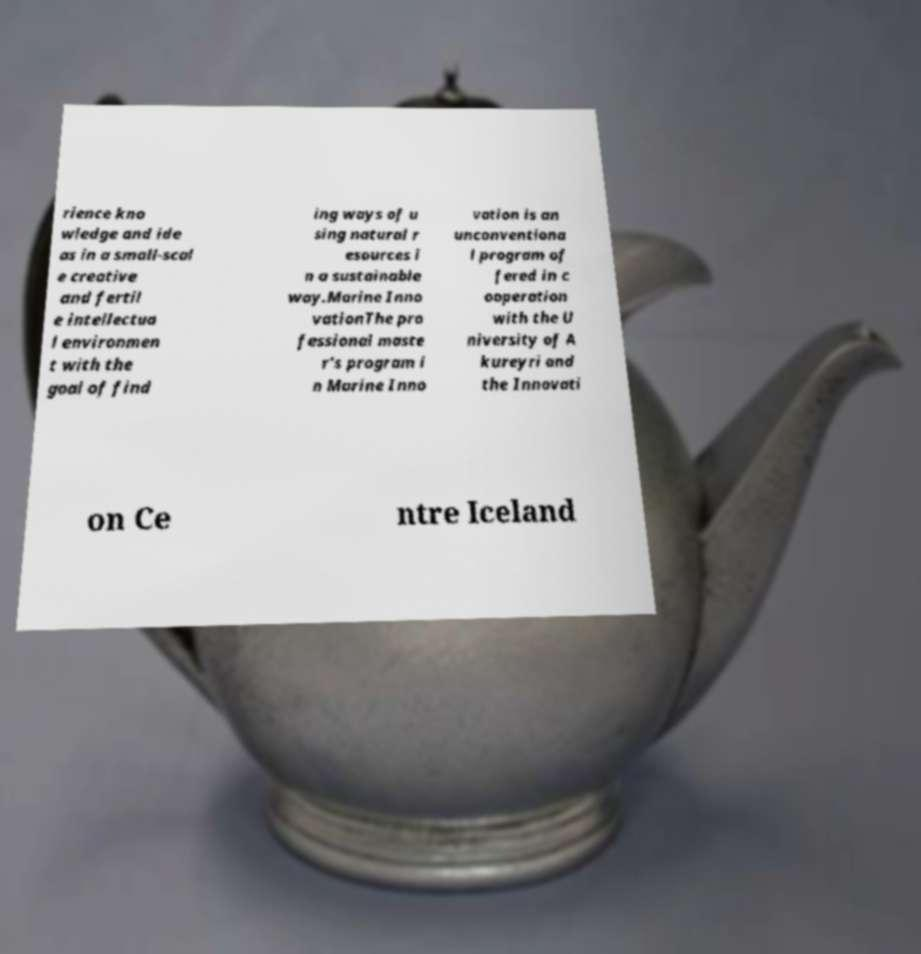Please read and relay the text visible in this image. What does it say? rience kno wledge and ide as in a small-scal e creative and fertil e intellectua l environmen t with the goal of find ing ways of u sing natural r esources i n a sustainable way.Marine Inno vationThe pro fessional maste r's program i n Marine Inno vation is an unconventiona l program of fered in c ooperation with the U niversity of A kureyri and the Innovati on Ce ntre Iceland 